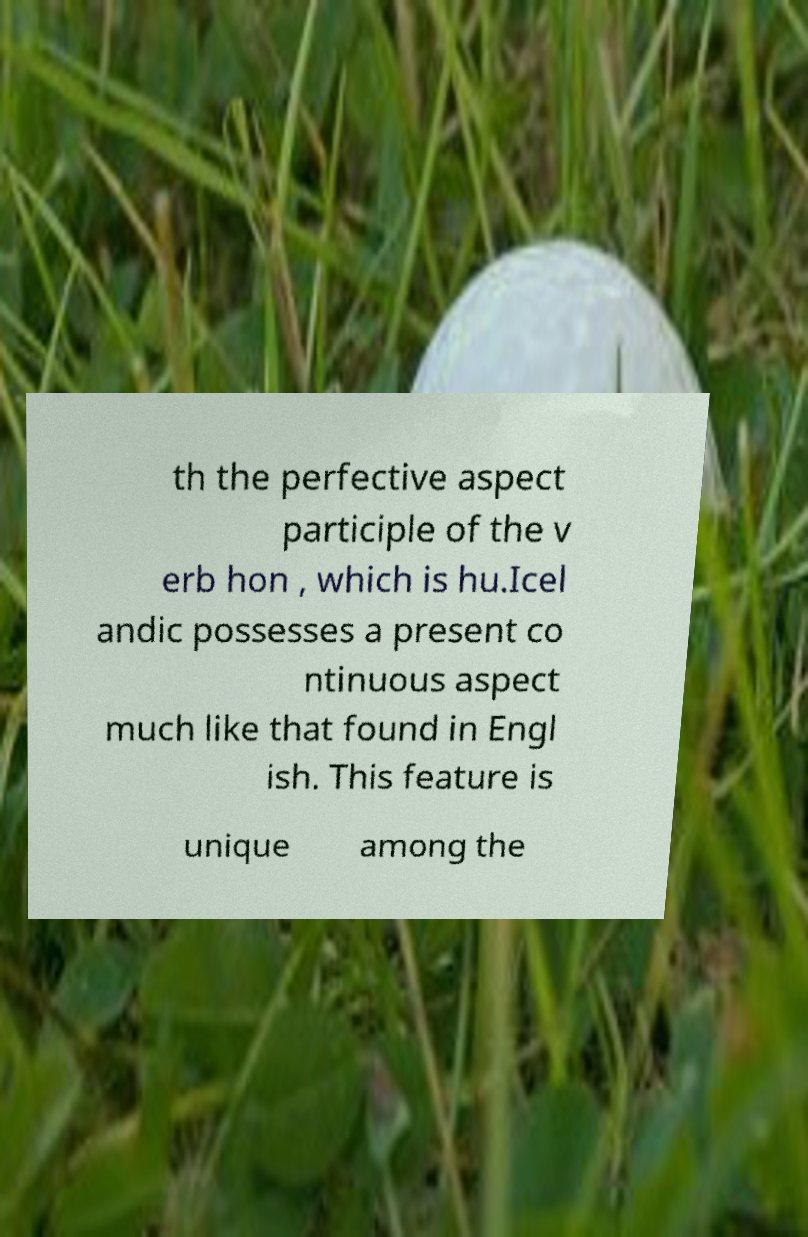Could you assist in decoding the text presented in this image and type it out clearly? th the perfective aspect participle of the v erb hon , which is hu.Icel andic possesses a present co ntinuous aspect much like that found in Engl ish. This feature is unique among the 